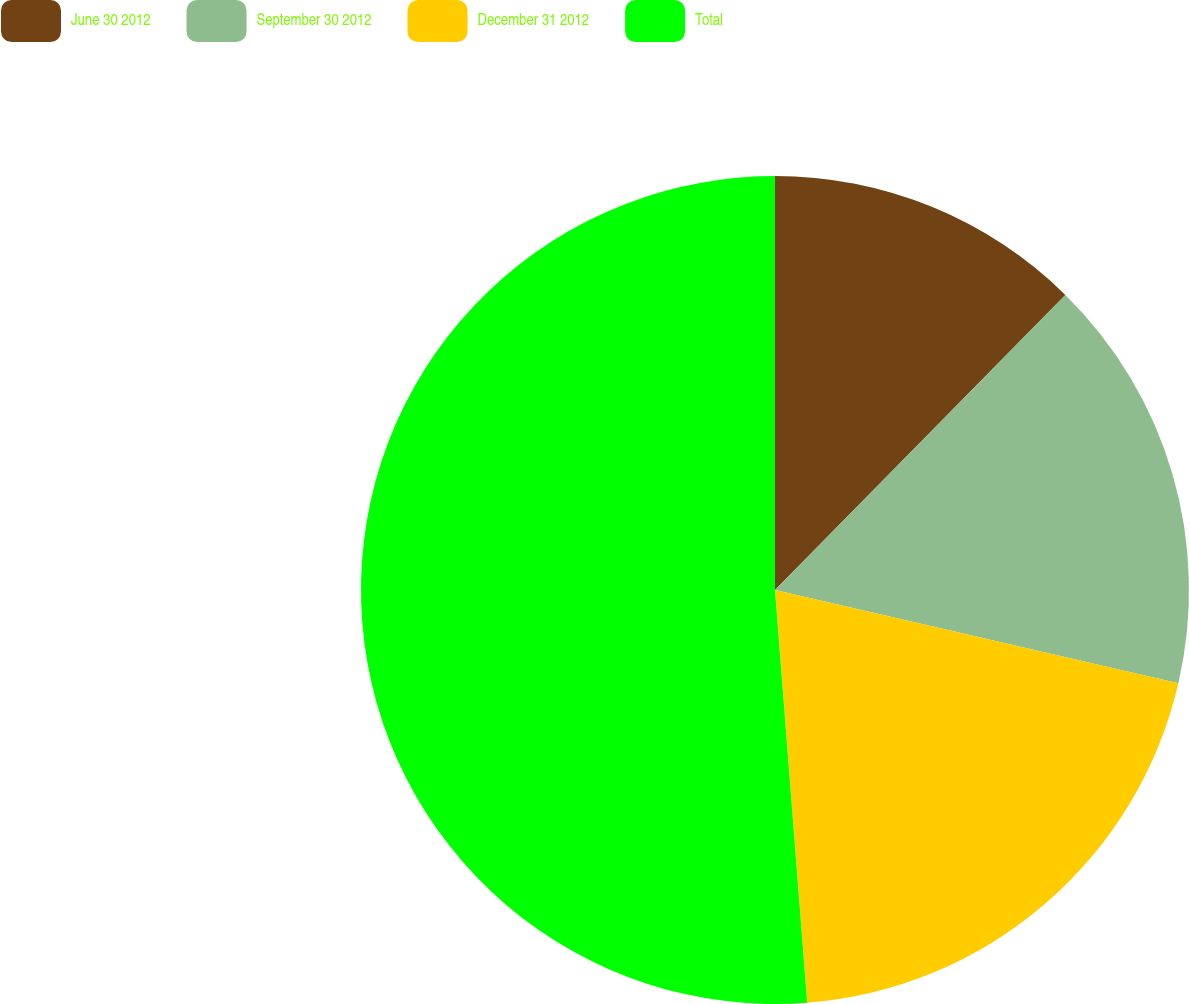Convert chart to OTSL. <chart><loc_0><loc_0><loc_500><loc_500><pie_chart><fcel>June 30 2012<fcel>September 30 2012<fcel>December 31 2012<fcel>Total<nl><fcel>12.37%<fcel>16.25%<fcel>20.14%<fcel>51.24%<nl></chart> 